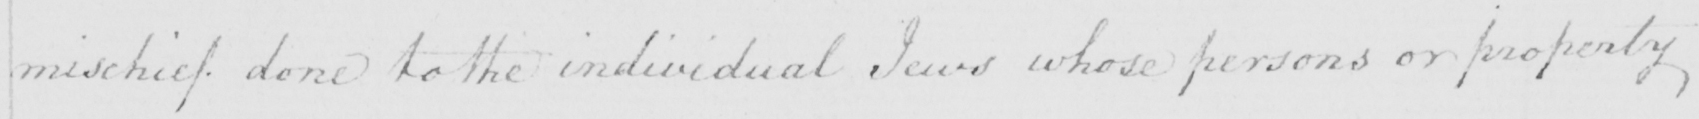Can you read and transcribe this handwriting? mischief done to the individual Jews whose persons or property 